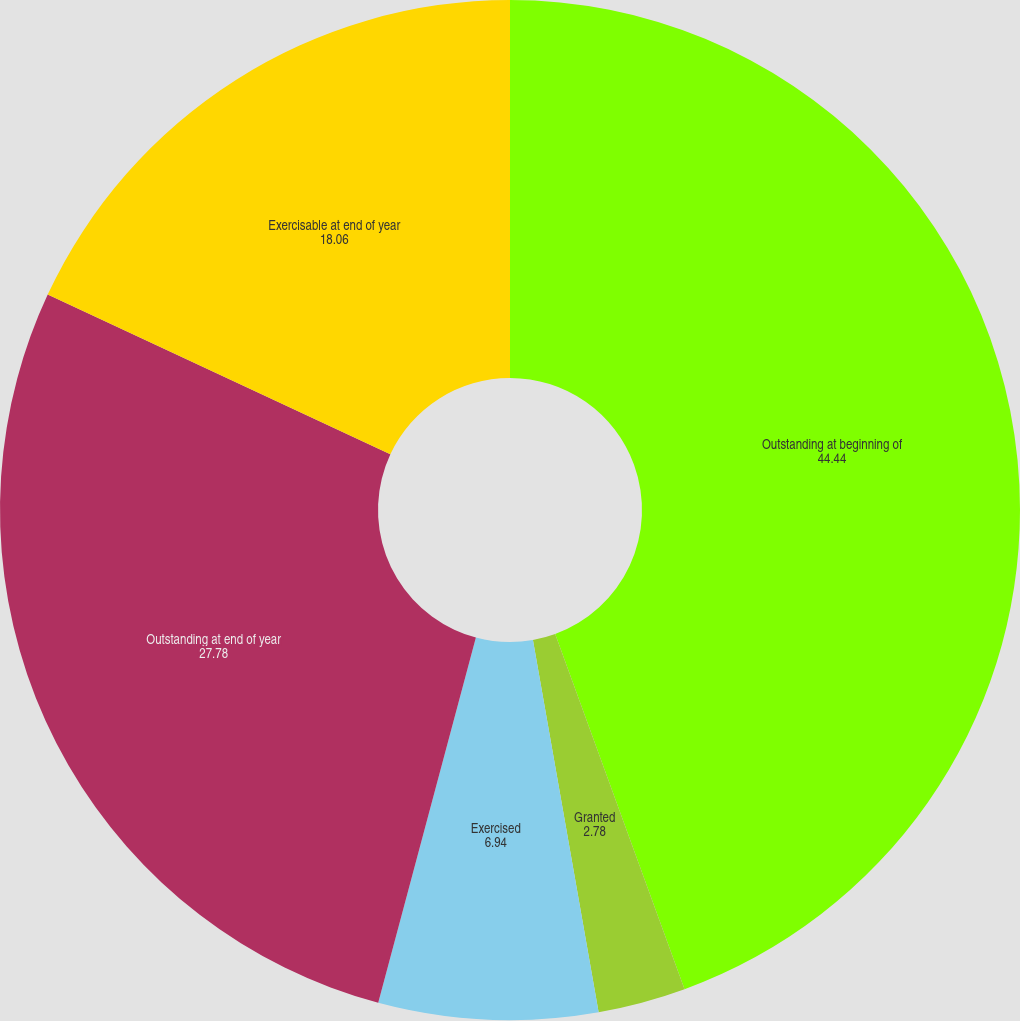<chart> <loc_0><loc_0><loc_500><loc_500><pie_chart><fcel>Outstanding at beginning of<fcel>Granted<fcel>Exercised<fcel>Outstanding at end of year<fcel>Exercisable at end of year<nl><fcel>44.44%<fcel>2.78%<fcel>6.94%<fcel>27.78%<fcel>18.06%<nl></chart> 